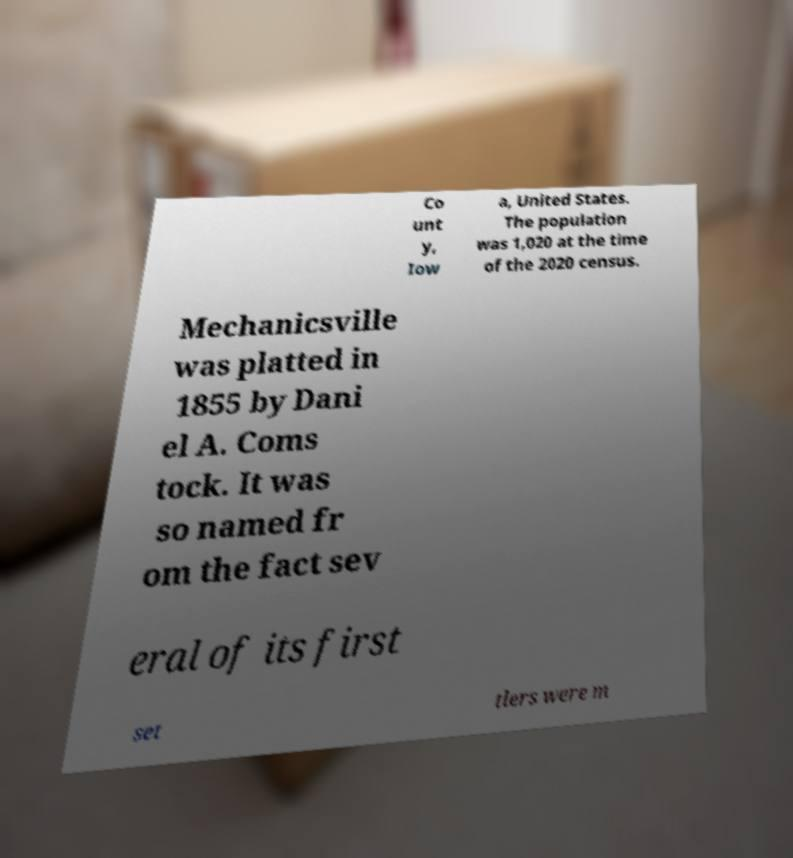What messages or text are displayed in this image? I need them in a readable, typed format. Co unt y, Iow a, United States. The population was 1,020 at the time of the 2020 census. Mechanicsville was platted in 1855 by Dani el A. Coms tock. It was so named fr om the fact sev eral of its first set tlers were m 